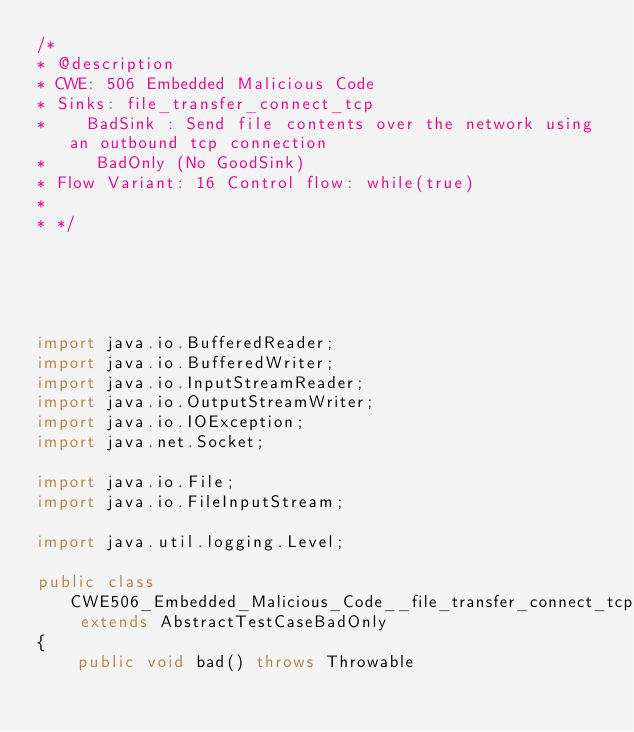<code> <loc_0><loc_0><loc_500><loc_500><_Java_>/*
* @description
* CWE: 506 Embedded Malicious Code
* Sinks: file_transfer_connect_tcp
*    BadSink : Send file contents over the network using an outbound tcp connection
*     BadOnly (No GoodSink)
* Flow Variant: 16 Control flow: while(true)
*
* */





import java.io.BufferedReader;
import java.io.BufferedWriter;
import java.io.InputStreamReader;
import java.io.OutputStreamWriter;
import java.io.IOException;
import java.net.Socket;

import java.io.File;
import java.io.FileInputStream;

import java.util.logging.Level;

public class CWE506_Embedded_Malicious_Code__file_transfer_connect_tcp_16 extends AbstractTestCaseBadOnly
{
    public void bad() throws Throwable</code> 